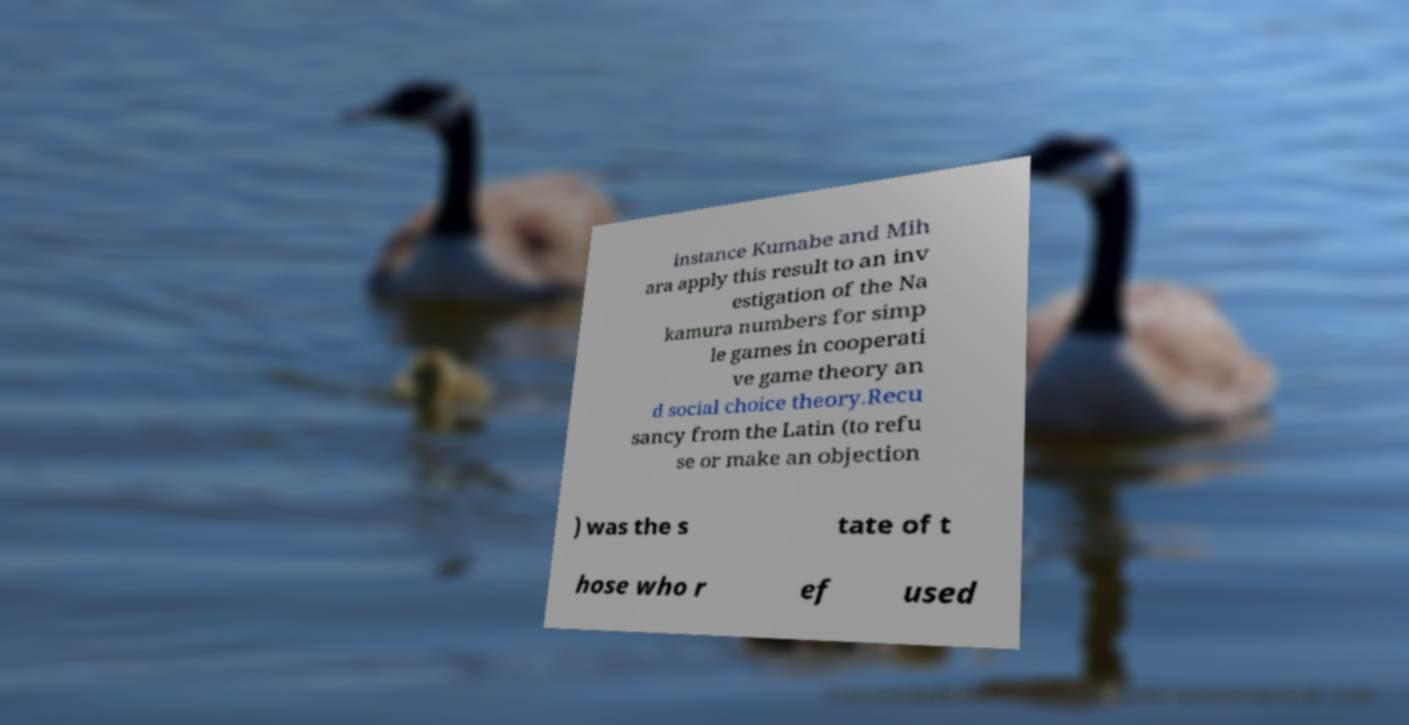Can you read and provide the text displayed in the image?This photo seems to have some interesting text. Can you extract and type it out for me? instance Kumabe and Mih ara apply this result to an inv estigation of the Na kamura numbers for simp le games in cooperati ve game theory an d social choice theory.Recu sancy from the Latin (to refu se or make an objection ) was the s tate of t hose who r ef used 